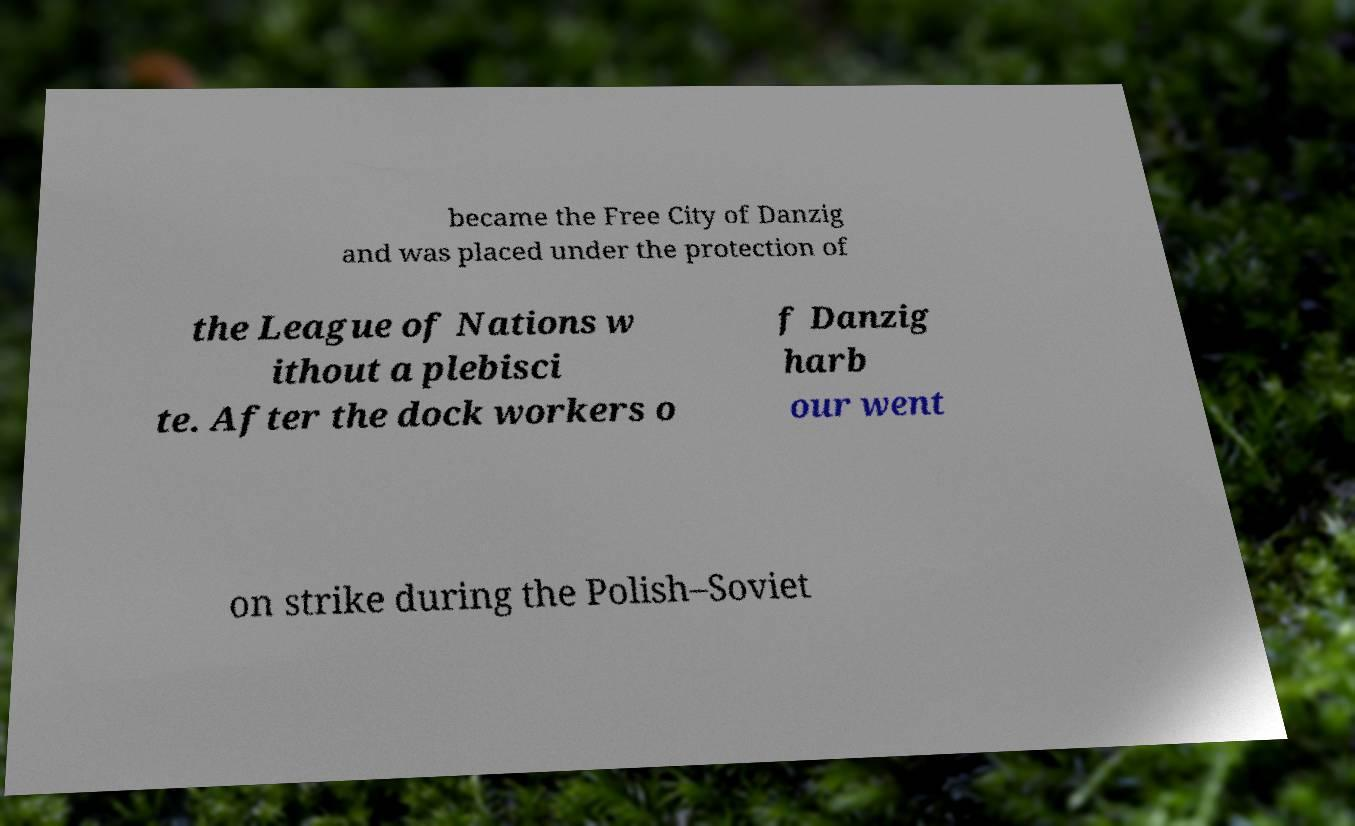Could you assist in decoding the text presented in this image and type it out clearly? became the Free City of Danzig and was placed under the protection of the League of Nations w ithout a plebisci te. After the dock workers o f Danzig harb our went on strike during the Polish–Soviet 